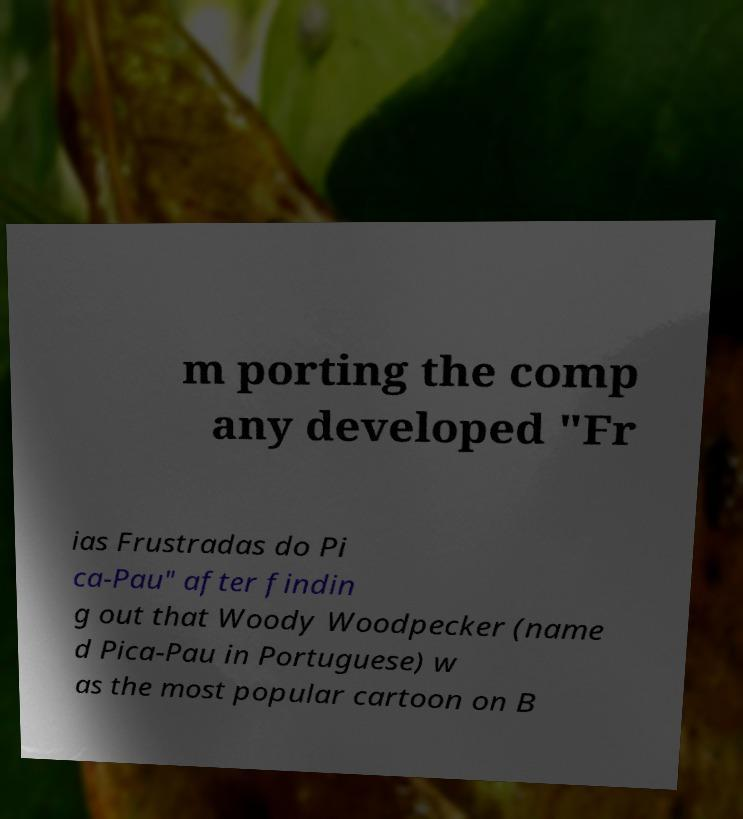Could you extract and type out the text from this image? m porting the comp any developed "Fr ias Frustradas do Pi ca-Pau" after findin g out that Woody Woodpecker (name d Pica-Pau in Portuguese) w as the most popular cartoon on B 